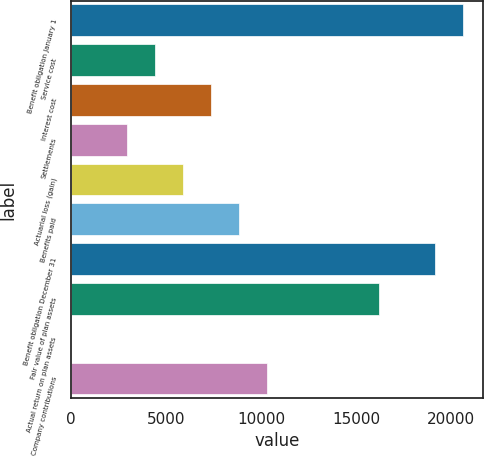Convert chart. <chart><loc_0><loc_0><loc_500><loc_500><bar_chart><fcel>Benefit obligation January 1<fcel>Service cost<fcel>Interest cost<fcel>Settlements<fcel>Actuarial loss (gain)<fcel>Benefits paid<fcel>Benefit obligation December 31<fcel>Fair value of plan assets<fcel>Actual return on plan assets<fcel>Company contributions<nl><fcel>20637<fcel>4423<fcel>7371<fcel>2949<fcel>5897<fcel>8845<fcel>19163<fcel>16215<fcel>1<fcel>10319<nl></chart> 